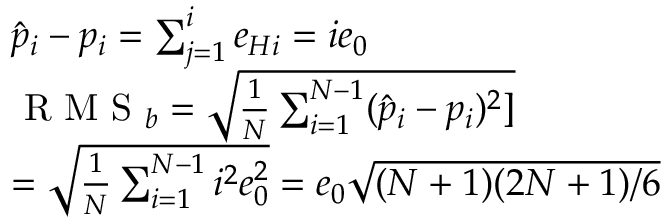Convert formula to latex. <formula><loc_0><loc_0><loc_500><loc_500>\begin{array} { r l } & { \hat { p } _ { i } - p _ { i } = \sum _ { j = 1 } ^ { i } e _ { H i } = i e _ { 0 } } \\ & { R M S _ { b } = \sqrt { \frac { 1 } { N } \sum _ { i = 1 } ^ { N - 1 } ( \hat { p } _ { i } - p _ { i } ) ^ { 2 } ] } } \\ & { = \sqrt { \frac { 1 } { N } \sum _ { i = 1 } ^ { N - 1 } i ^ { 2 } e _ { 0 } ^ { 2 } } = e _ { 0 } \sqrt { ( N + 1 ) ( 2 N + 1 ) / 6 } } \end{array}</formula> 